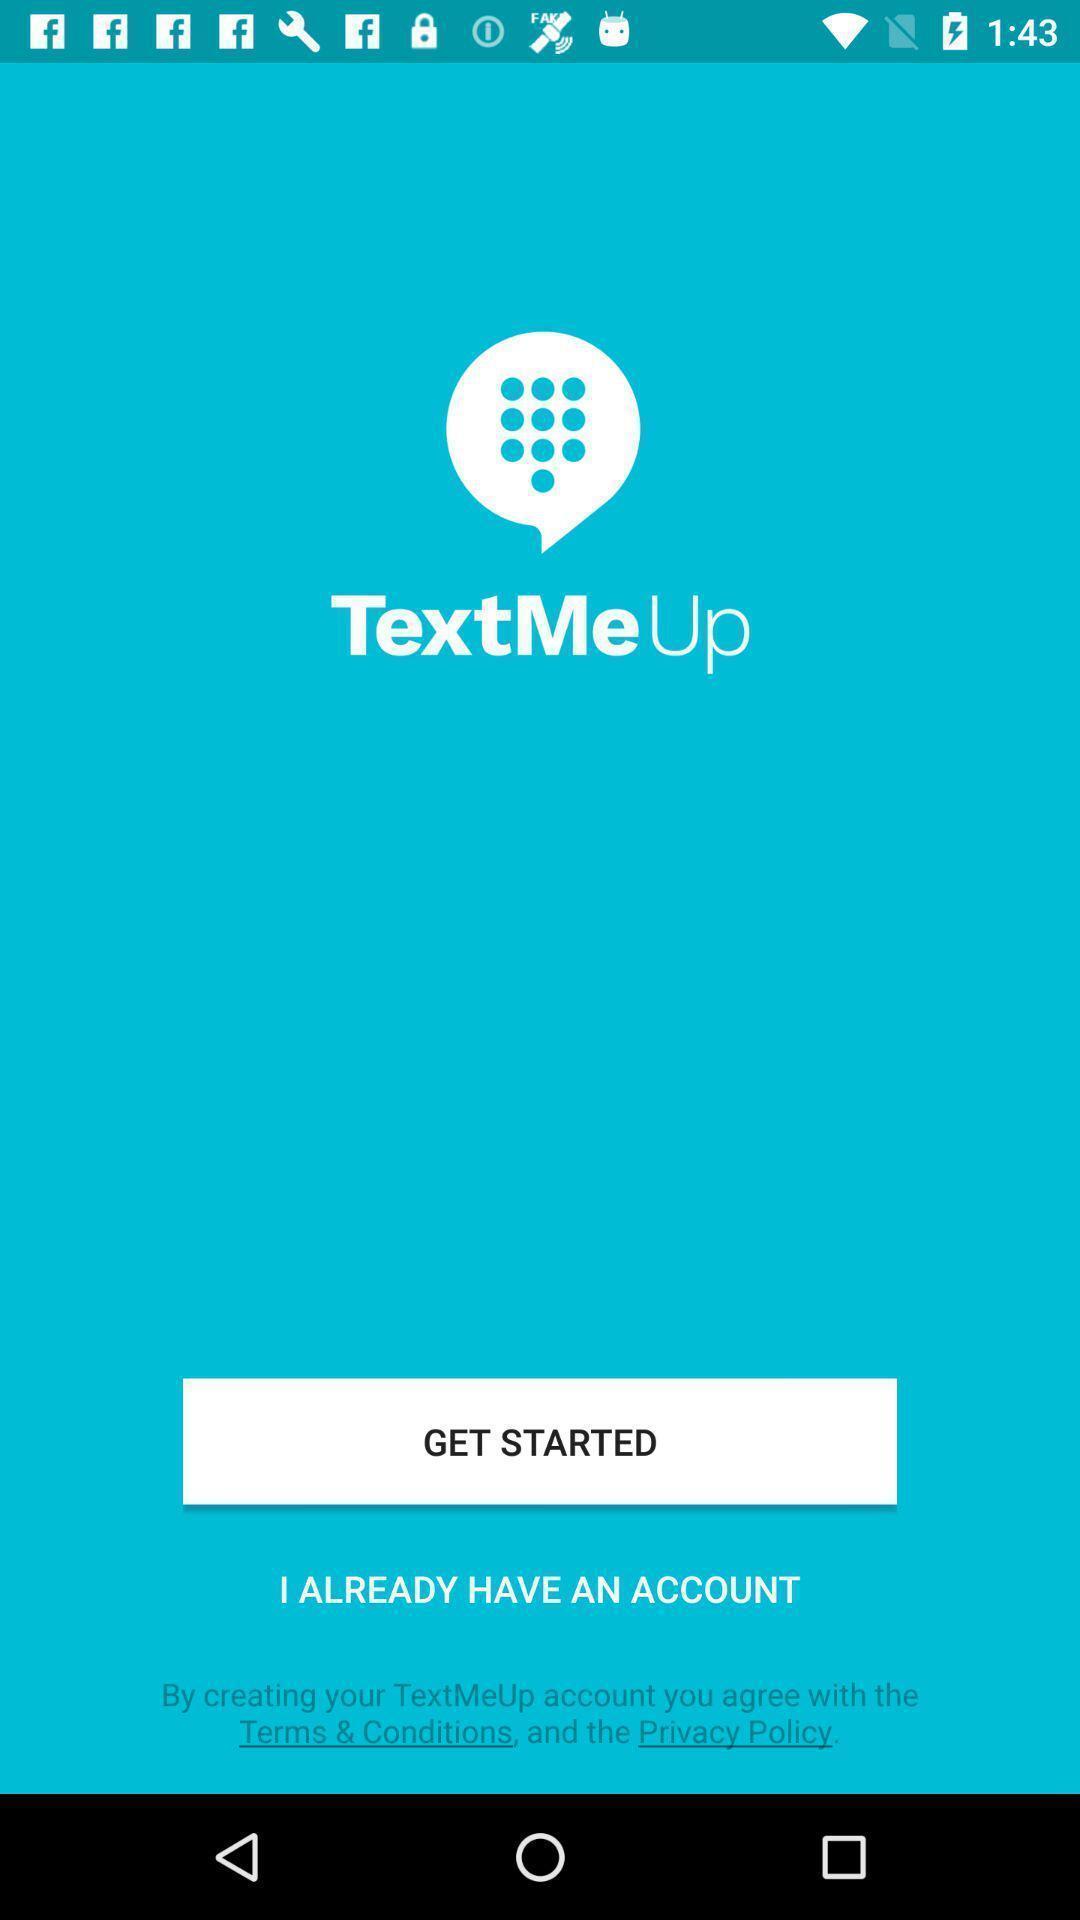Provide a detailed account of this screenshot. Welcome page of a texting application. 